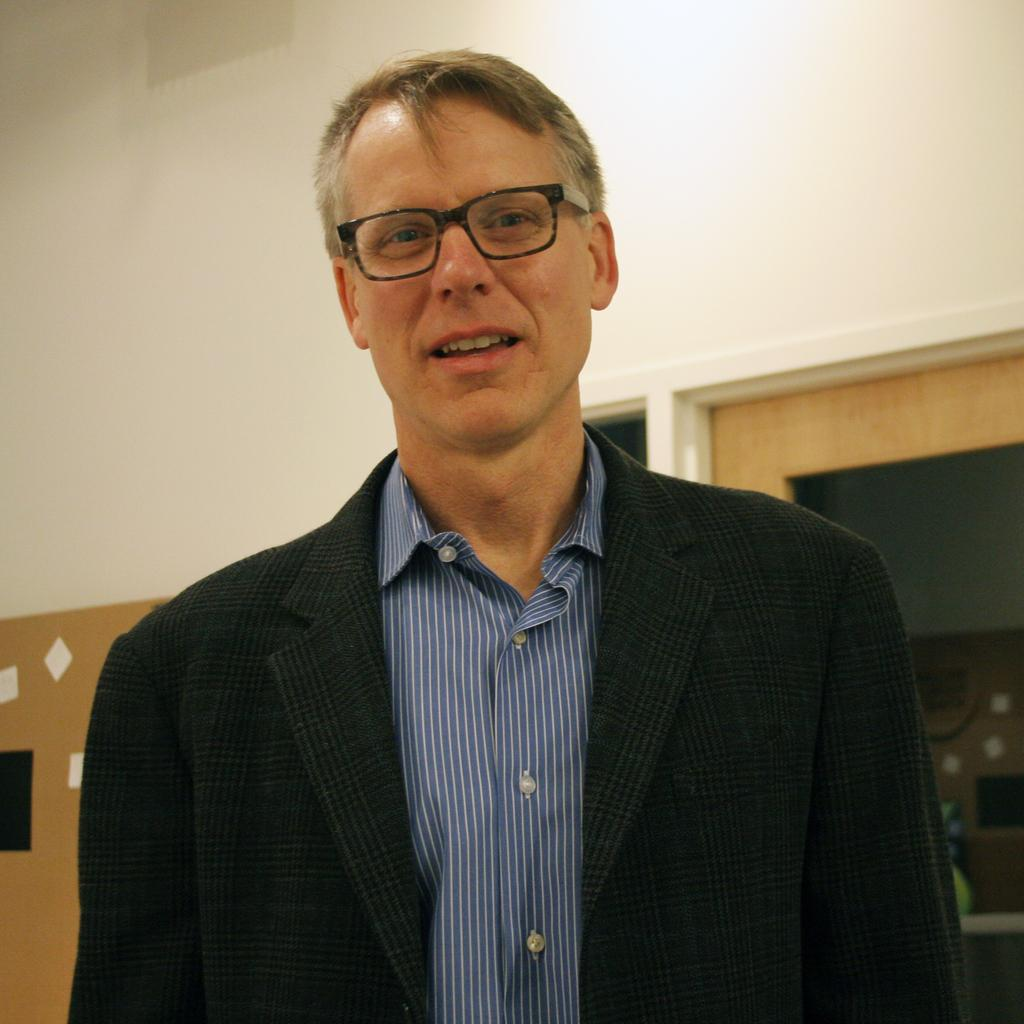Who is present in the image? There is a man in the image. What is the man wearing? The man is wearing a black jacket and a blue shirt with white lines. What can be seen in the background of the image? There is a wall in the background of the image. What feature does the wall have? The wall has windows. Can you see any waves in the image? There are no waves present in the image; it features a man wearing a black jacket and a blue shirt with white lines, with a wall and windows in the background. 